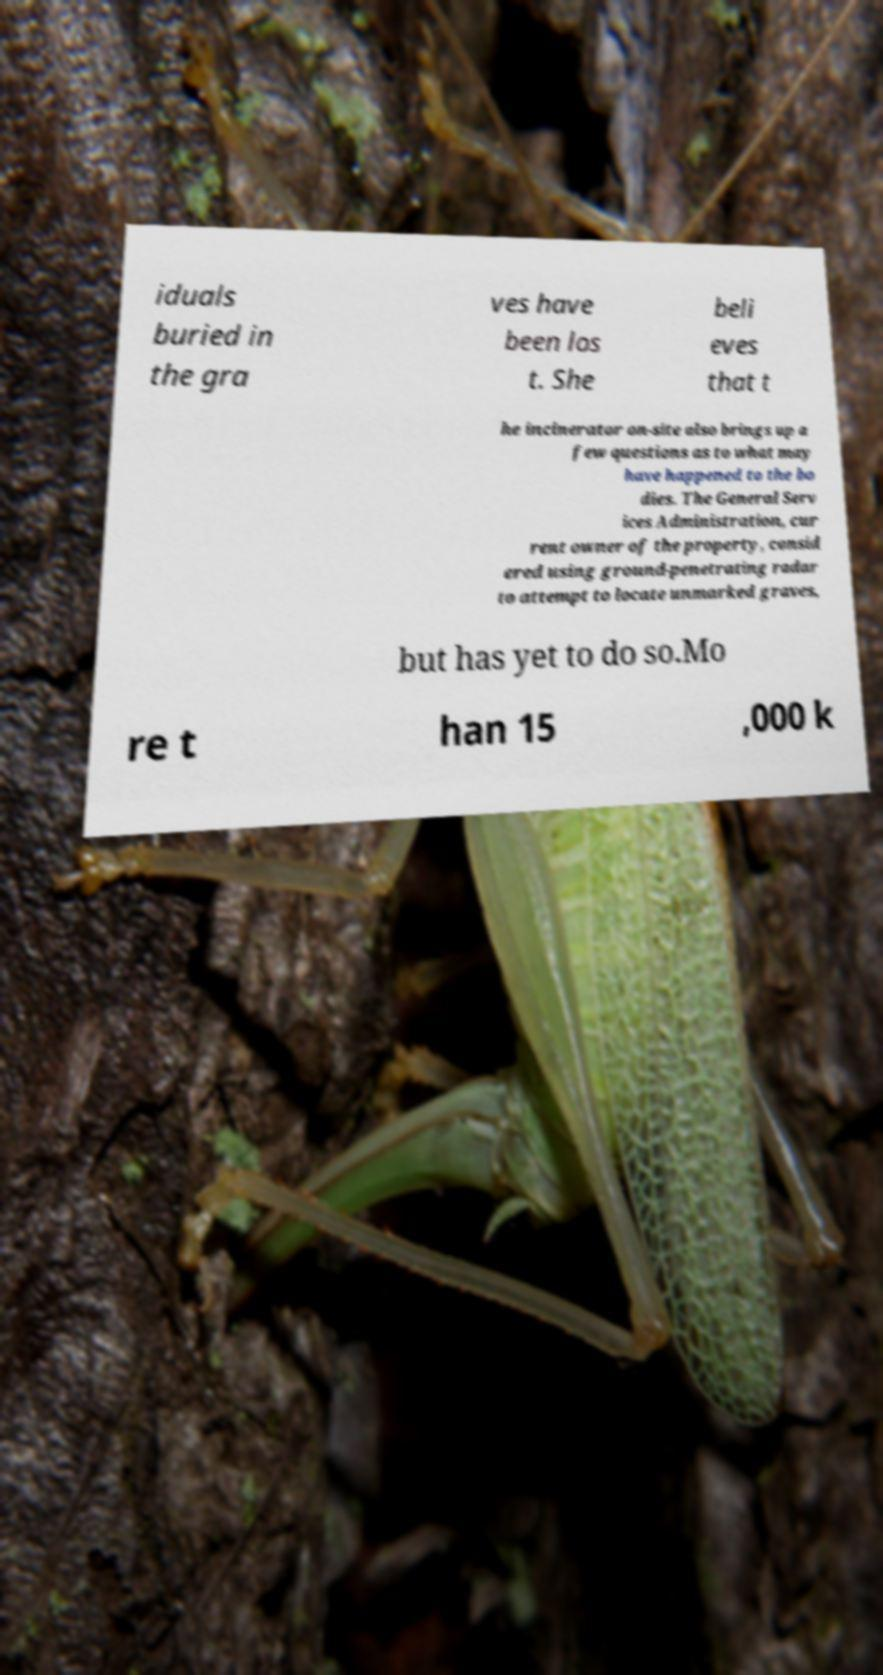Please identify and transcribe the text found in this image. iduals buried in the gra ves have been los t. She beli eves that t he incinerator on-site also brings up a few questions as to what may have happened to the bo dies. The General Serv ices Administration, cur rent owner of the property, consid ered using ground-penetrating radar to attempt to locate unmarked graves, but has yet to do so.Mo re t han 15 ,000 k 